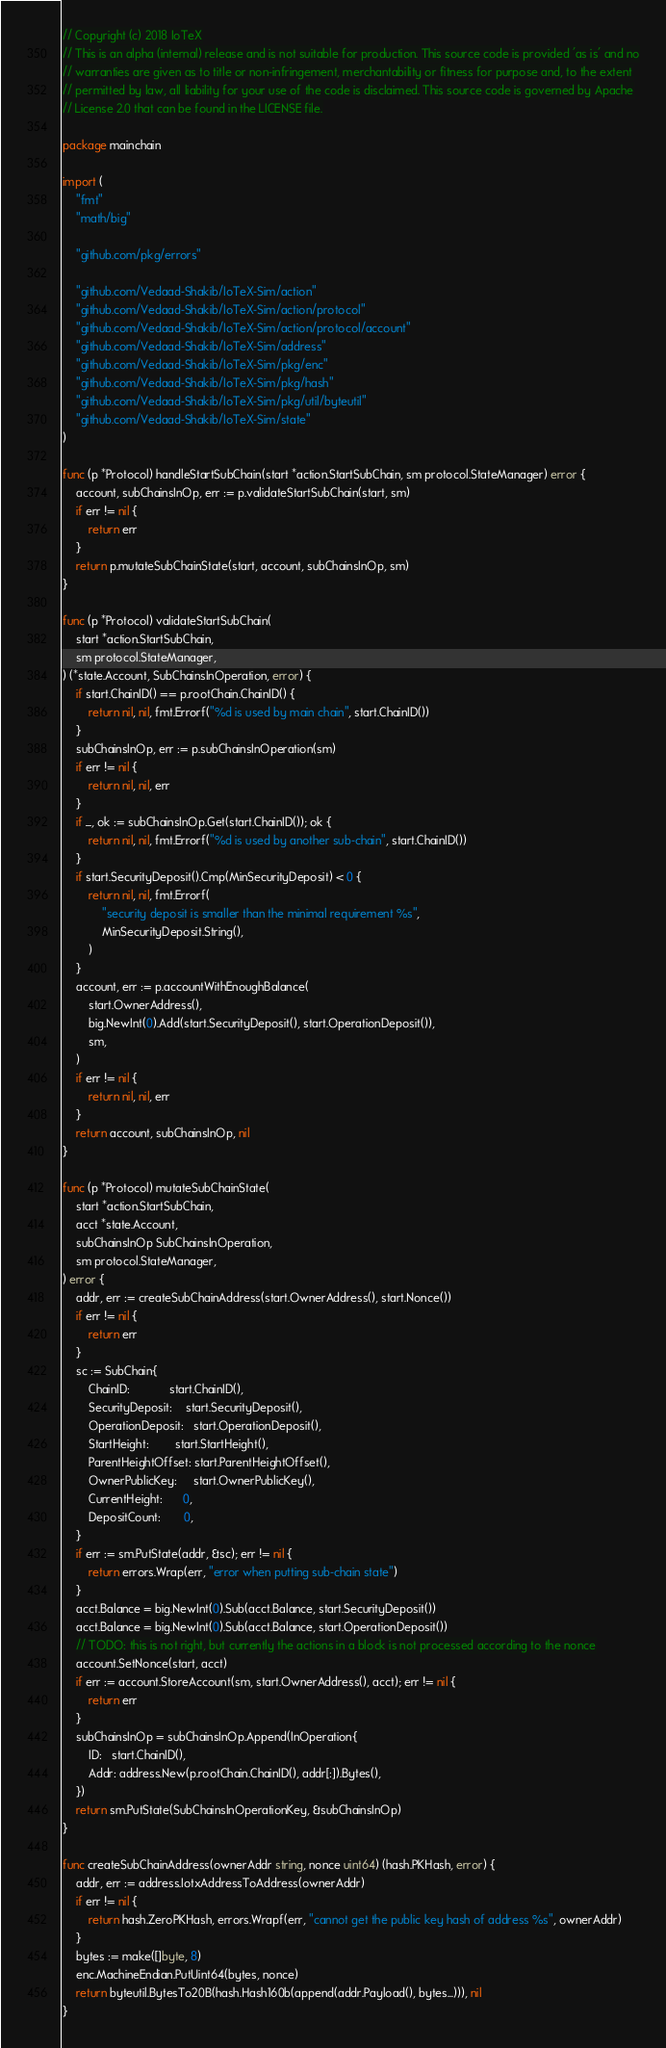<code> <loc_0><loc_0><loc_500><loc_500><_Go_>// Copyright (c) 2018 IoTeX
// This is an alpha (internal) release and is not suitable for production. This source code is provided 'as is' and no
// warranties are given as to title or non-infringement, merchantability or fitness for purpose and, to the extent
// permitted by law, all liability for your use of the code is disclaimed. This source code is governed by Apache
// License 2.0 that can be found in the LICENSE file.

package mainchain

import (
	"fmt"
	"math/big"

	"github.com/pkg/errors"

	"github.com/Vedaad-Shakib/IoTeX-Sim/action"
	"github.com/Vedaad-Shakib/IoTeX-Sim/action/protocol"
	"github.com/Vedaad-Shakib/IoTeX-Sim/action/protocol/account"
	"github.com/Vedaad-Shakib/IoTeX-Sim/address"
	"github.com/Vedaad-Shakib/IoTeX-Sim/pkg/enc"
	"github.com/Vedaad-Shakib/IoTeX-Sim/pkg/hash"
	"github.com/Vedaad-Shakib/IoTeX-Sim/pkg/util/byteutil"
	"github.com/Vedaad-Shakib/IoTeX-Sim/state"
)

func (p *Protocol) handleStartSubChain(start *action.StartSubChain, sm protocol.StateManager) error {
	account, subChainsInOp, err := p.validateStartSubChain(start, sm)
	if err != nil {
		return err
	}
	return p.mutateSubChainState(start, account, subChainsInOp, sm)
}

func (p *Protocol) validateStartSubChain(
	start *action.StartSubChain,
	sm protocol.StateManager,
) (*state.Account, SubChainsInOperation, error) {
	if start.ChainID() == p.rootChain.ChainID() {
		return nil, nil, fmt.Errorf("%d is used by main chain", start.ChainID())
	}
	subChainsInOp, err := p.subChainsInOperation(sm)
	if err != nil {
		return nil, nil, err
	}
	if _, ok := subChainsInOp.Get(start.ChainID()); ok {
		return nil, nil, fmt.Errorf("%d is used by another sub-chain", start.ChainID())
	}
	if start.SecurityDeposit().Cmp(MinSecurityDeposit) < 0 {
		return nil, nil, fmt.Errorf(
			"security deposit is smaller than the minimal requirement %s",
			MinSecurityDeposit.String(),
		)
	}
	account, err := p.accountWithEnoughBalance(
		start.OwnerAddress(),
		big.NewInt(0).Add(start.SecurityDeposit(), start.OperationDeposit()),
		sm,
	)
	if err != nil {
		return nil, nil, err
	}
	return account, subChainsInOp, nil
}

func (p *Protocol) mutateSubChainState(
	start *action.StartSubChain,
	acct *state.Account,
	subChainsInOp SubChainsInOperation,
	sm protocol.StateManager,
) error {
	addr, err := createSubChainAddress(start.OwnerAddress(), start.Nonce())
	if err != nil {
		return err
	}
	sc := SubChain{
		ChainID:            start.ChainID(),
		SecurityDeposit:    start.SecurityDeposit(),
		OperationDeposit:   start.OperationDeposit(),
		StartHeight:        start.StartHeight(),
		ParentHeightOffset: start.ParentHeightOffset(),
		OwnerPublicKey:     start.OwnerPublicKey(),
		CurrentHeight:      0,
		DepositCount:       0,
	}
	if err := sm.PutState(addr, &sc); err != nil {
		return errors.Wrap(err, "error when putting sub-chain state")
	}
	acct.Balance = big.NewInt(0).Sub(acct.Balance, start.SecurityDeposit())
	acct.Balance = big.NewInt(0).Sub(acct.Balance, start.OperationDeposit())
	// TODO: this is not right, but currently the actions in a block is not processed according to the nonce
	account.SetNonce(start, acct)
	if err := account.StoreAccount(sm, start.OwnerAddress(), acct); err != nil {
		return err
	}
	subChainsInOp = subChainsInOp.Append(InOperation{
		ID:   start.ChainID(),
		Addr: address.New(p.rootChain.ChainID(), addr[:]).Bytes(),
	})
	return sm.PutState(SubChainsInOperationKey, &subChainsInOp)
}

func createSubChainAddress(ownerAddr string, nonce uint64) (hash.PKHash, error) {
	addr, err := address.IotxAddressToAddress(ownerAddr)
	if err != nil {
		return hash.ZeroPKHash, errors.Wrapf(err, "cannot get the public key hash of address %s", ownerAddr)
	}
	bytes := make([]byte, 8)
	enc.MachineEndian.PutUint64(bytes, nonce)
	return byteutil.BytesTo20B(hash.Hash160b(append(addr.Payload(), bytes...))), nil
}
</code> 